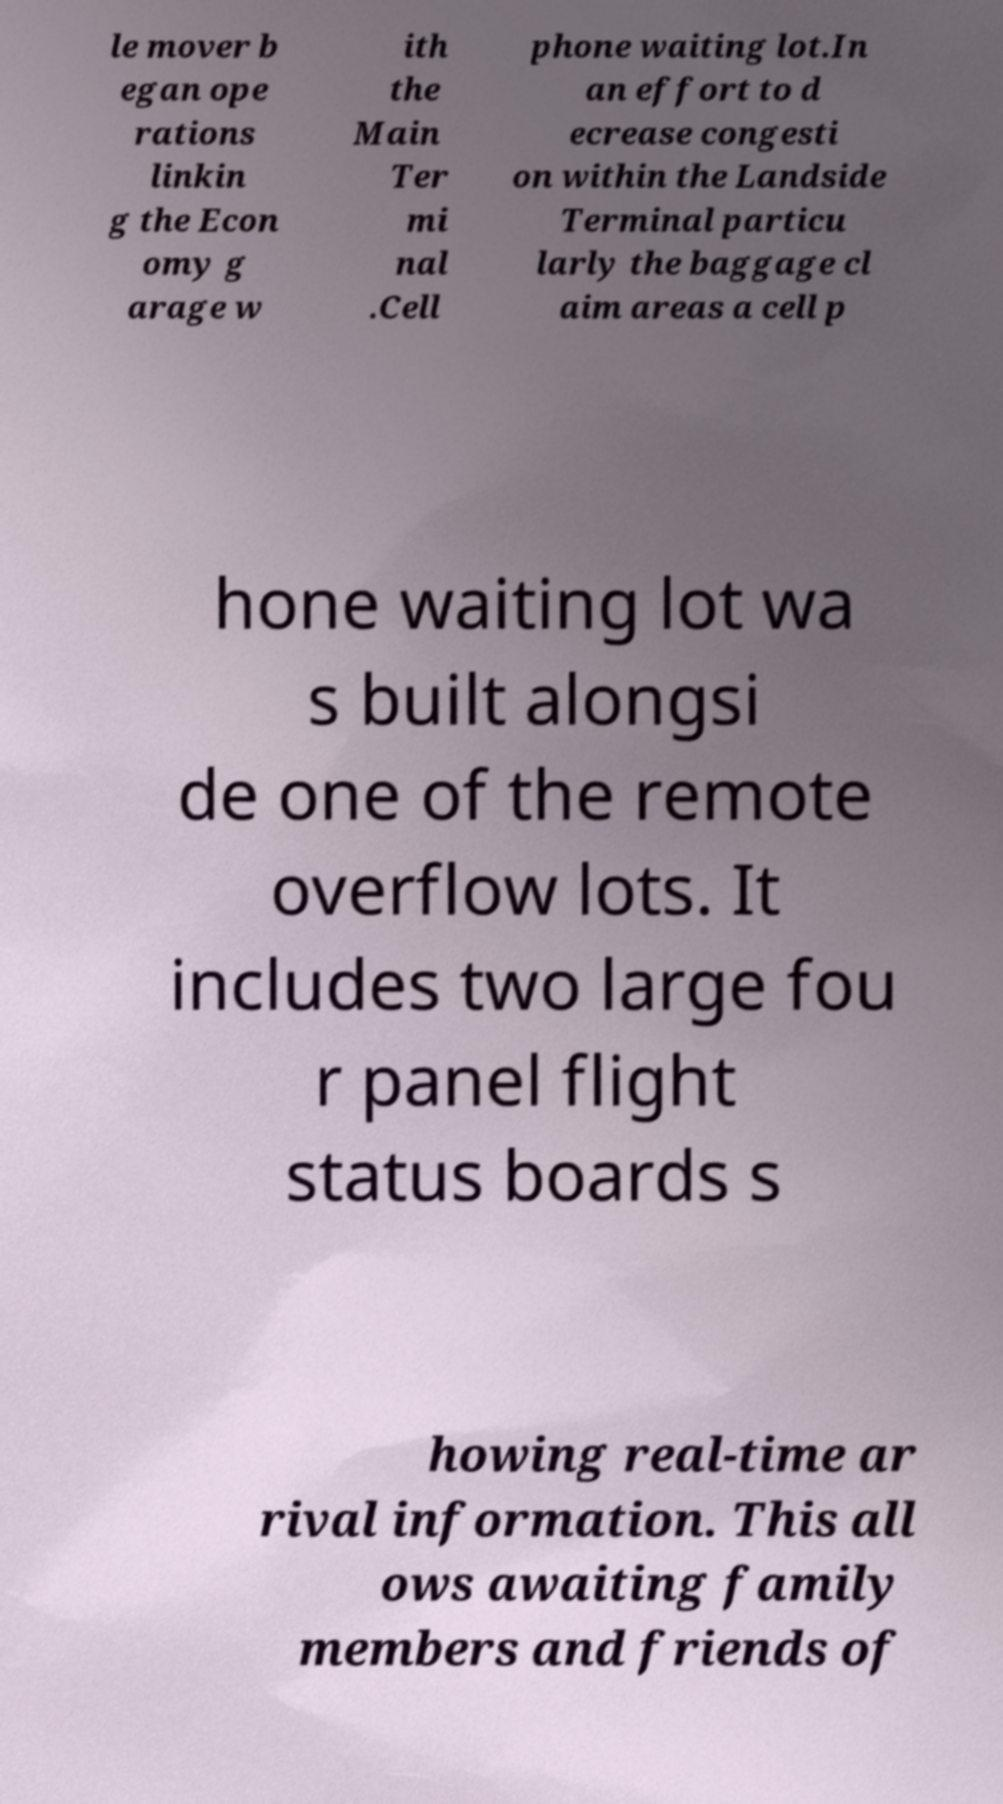There's text embedded in this image that I need extracted. Can you transcribe it verbatim? le mover b egan ope rations linkin g the Econ omy g arage w ith the Main Ter mi nal .Cell phone waiting lot.In an effort to d ecrease congesti on within the Landside Terminal particu larly the baggage cl aim areas a cell p hone waiting lot wa s built alongsi de one of the remote overflow lots. It includes two large fou r panel flight status boards s howing real-time ar rival information. This all ows awaiting family members and friends of 